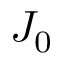<formula> <loc_0><loc_0><loc_500><loc_500>J _ { 0 }</formula> 